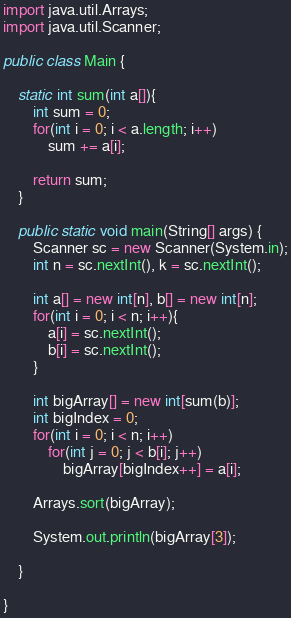<code> <loc_0><loc_0><loc_500><loc_500><_Java_>
import java.util.Arrays;
import java.util.Scanner;

public class Main {
	
	static int sum(int a[]){
		int sum = 0;
		for(int i = 0; i < a.length; i++)
			sum += a[i];
		
		return sum;
	}
 
	public static void main(String[] args) {
		Scanner sc = new Scanner(System.in);
		int n = sc.nextInt(), k = sc.nextInt();
		
		int a[] = new int[n], b[] = new int[n];
		for(int i = 0; i < n; i++){
			a[i] = sc.nextInt();
			b[i] = sc.nextInt();
		}
		
		int bigArray[] = new int[sum(b)];
		int bigIndex = 0;
		for(int i = 0; i < n; i++)
			for(int j = 0; j < b[i]; j++)
				bigArray[bigIndex++] = a[i];
		
		Arrays.sort(bigArray);
		
		System.out.println(bigArray[3]);
		
	}
 
}</code> 